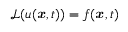<formula> <loc_0><loc_0><loc_500><loc_500>\mathcal { L } ( u ( { x } , t ) ) = f ( { x } , t )</formula> 